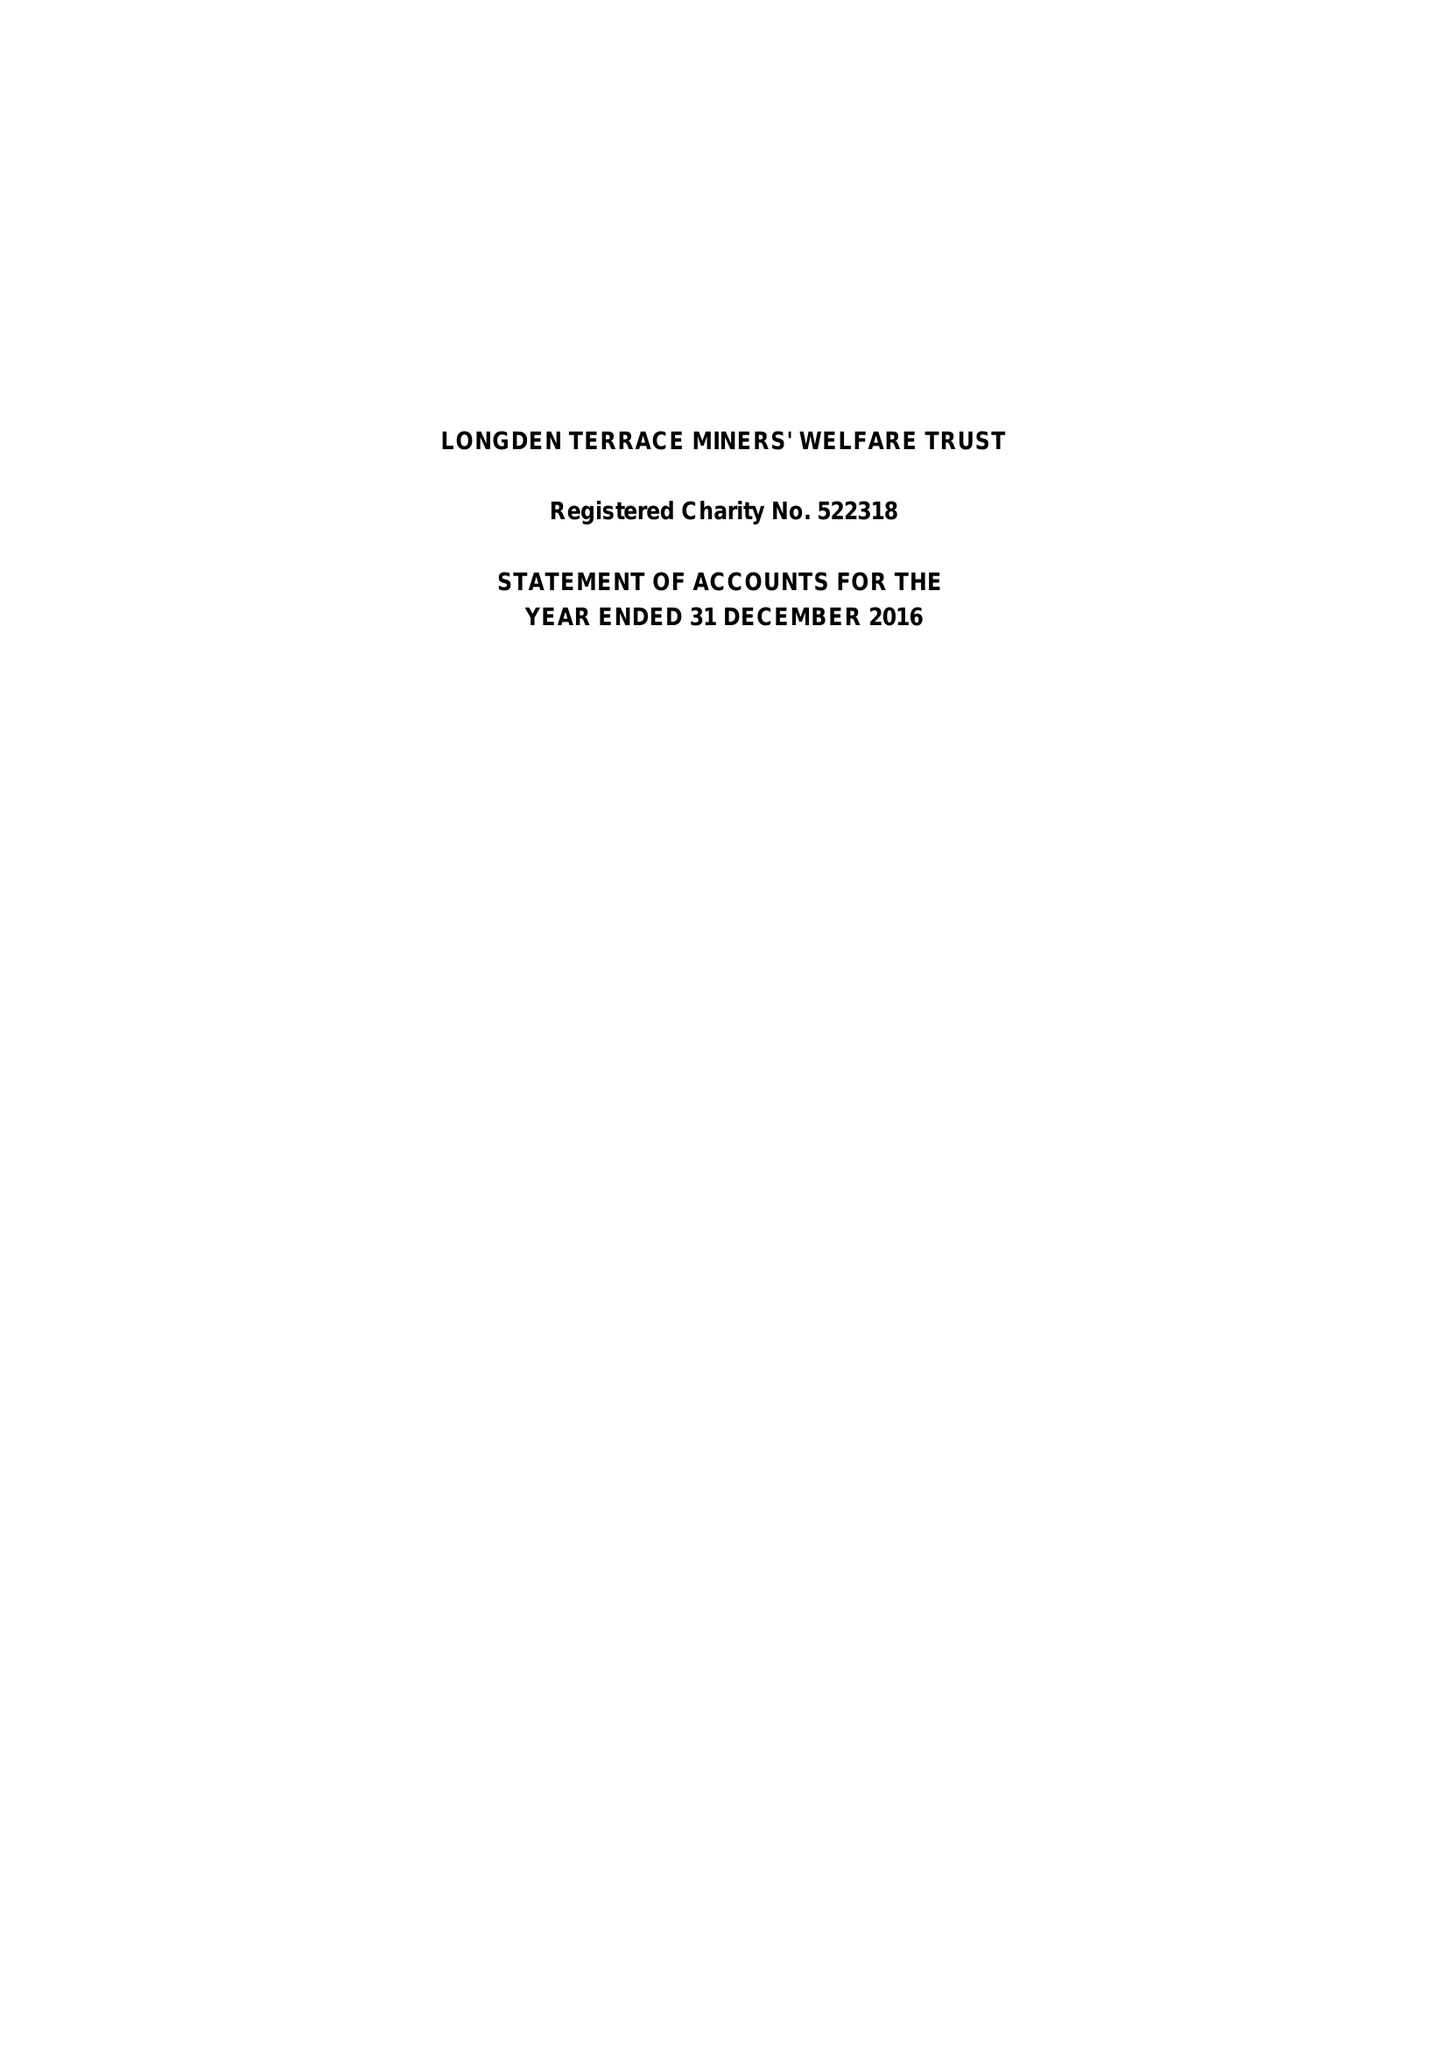What is the value for the spending_annually_in_british_pounds?
Answer the question using a single word or phrase. 58486.00 